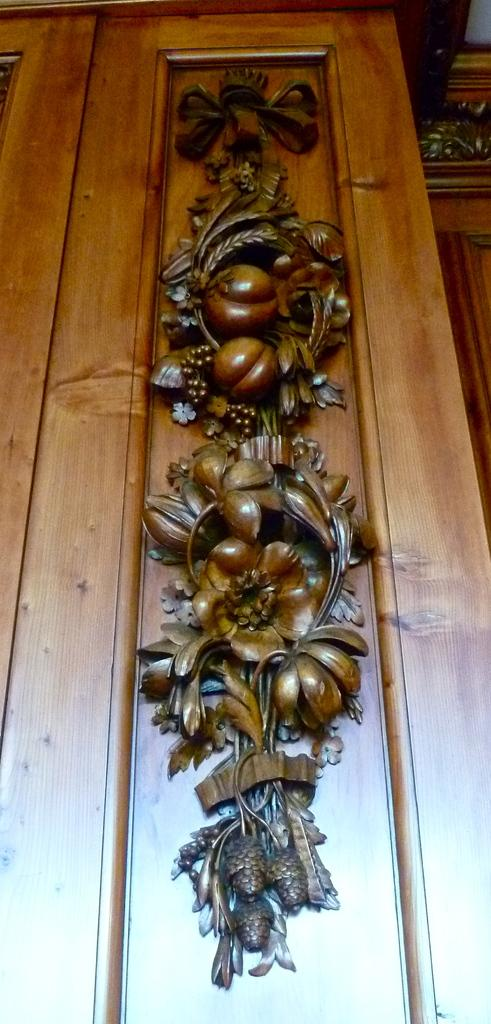What type of door is visible in the image? There is a wooden door in the image. Can you describe the design on the wooden door? The wooden door has a design on it. What type of meat can be seen cooking in a stream near the wooden door? There is no meat or stream present in the image; it only features a wooden door with a design on it. 